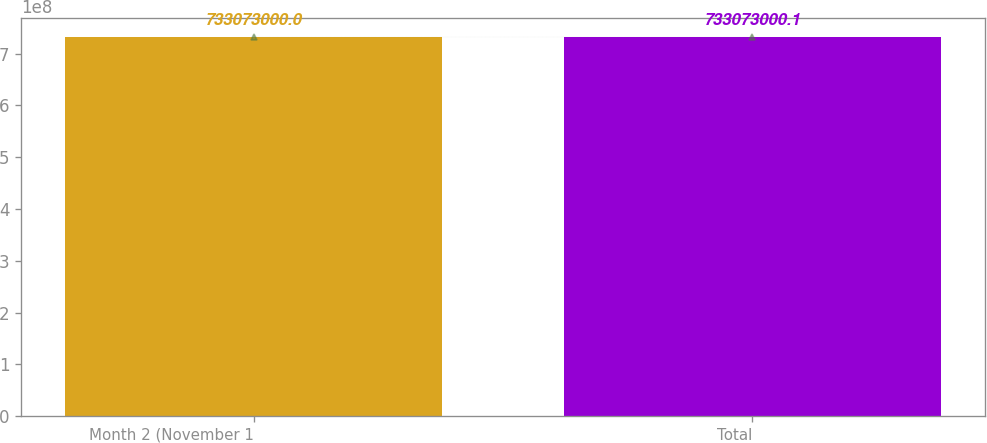Convert chart to OTSL. <chart><loc_0><loc_0><loc_500><loc_500><bar_chart><fcel>Month 2 (November 1<fcel>Total<nl><fcel>7.33073e+08<fcel>7.33073e+08<nl></chart> 